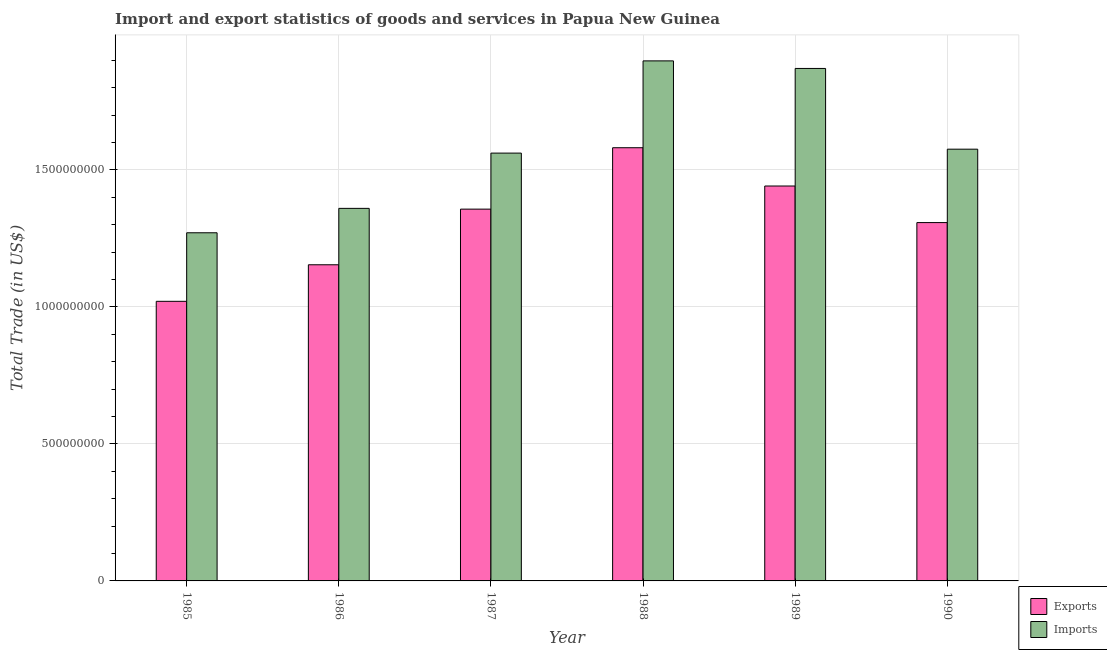How many different coloured bars are there?
Offer a very short reply. 2. How many bars are there on the 6th tick from the right?
Offer a terse response. 2. In how many cases, is the number of bars for a given year not equal to the number of legend labels?
Ensure brevity in your answer.  0. What is the imports of goods and services in 1989?
Provide a succinct answer. 1.87e+09. Across all years, what is the maximum imports of goods and services?
Make the answer very short. 1.90e+09. Across all years, what is the minimum imports of goods and services?
Ensure brevity in your answer.  1.27e+09. What is the total export of goods and services in the graph?
Your response must be concise. 7.86e+09. What is the difference between the imports of goods and services in 1985 and that in 1988?
Ensure brevity in your answer.  -6.27e+08. What is the difference between the export of goods and services in 1989 and the imports of goods and services in 1987?
Keep it short and to the point. 8.45e+07. What is the average imports of goods and services per year?
Your answer should be very brief. 1.59e+09. In how many years, is the export of goods and services greater than 200000000 US$?
Ensure brevity in your answer.  6. What is the ratio of the export of goods and services in 1989 to that in 1990?
Offer a very short reply. 1.1. Is the imports of goods and services in 1988 less than that in 1989?
Make the answer very short. No. What is the difference between the highest and the second highest imports of goods and services?
Provide a succinct answer. 2.76e+07. What is the difference between the highest and the lowest imports of goods and services?
Make the answer very short. 6.27e+08. What does the 2nd bar from the left in 1990 represents?
Make the answer very short. Imports. What does the 1st bar from the right in 1989 represents?
Offer a very short reply. Imports. How many bars are there?
Your answer should be compact. 12. Are all the bars in the graph horizontal?
Keep it short and to the point. No. What is the difference between two consecutive major ticks on the Y-axis?
Your answer should be very brief. 5.00e+08. Where does the legend appear in the graph?
Give a very brief answer. Bottom right. How are the legend labels stacked?
Give a very brief answer. Vertical. What is the title of the graph?
Provide a short and direct response. Import and export statistics of goods and services in Papua New Guinea. Does "Goods and services" appear as one of the legend labels in the graph?
Your response must be concise. No. What is the label or title of the X-axis?
Provide a short and direct response. Year. What is the label or title of the Y-axis?
Provide a succinct answer. Total Trade (in US$). What is the Total Trade (in US$) of Exports in 1985?
Offer a very short reply. 1.02e+09. What is the Total Trade (in US$) of Imports in 1985?
Provide a succinct answer. 1.27e+09. What is the Total Trade (in US$) in Exports in 1986?
Offer a terse response. 1.15e+09. What is the Total Trade (in US$) in Imports in 1986?
Your response must be concise. 1.36e+09. What is the Total Trade (in US$) of Exports in 1987?
Keep it short and to the point. 1.36e+09. What is the Total Trade (in US$) in Imports in 1987?
Keep it short and to the point. 1.56e+09. What is the Total Trade (in US$) of Exports in 1988?
Offer a terse response. 1.58e+09. What is the Total Trade (in US$) in Imports in 1988?
Offer a very short reply. 1.90e+09. What is the Total Trade (in US$) in Exports in 1989?
Keep it short and to the point. 1.44e+09. What is the Total Trade (in US$) in Imports in 1989?
Your answer should be very brief. 1.87e+09. What is the Total Trade (in US$) in Exports in 1990?
Your response must be concise. 1.31e+09. What is the Total Trade (in US$) in Imports in 1990?
Provide a short and direct response. 1.58e+09. Across all years, what is the maximum Total Trade (in US$) in Exports?
Provide a succinct answer. 1.58e+09. Across all years, what is the maximum Total Trade (in US$) in Imports?
Your answer should be compact. 1.90e+09. Across all years, what is the minimum Total Trade (in US$) of Exports?
Make the answer very short. 1.02e+09. Across all years, what is the minimum Total Trade (in US$) of Imports?
Provide a short and direct response. 1.27e+09. What is the total Total Trade (in US$) in Exports in the graph?
Offer a terse response. 7.86e+09. What is the total Total Trade (in US$) of Imports in the graph?
Keep it short and to the point. 9.54e+09. What is the difference between the Total Trade (in US$) in Exports in 1985 and that in 1986?
Your response must be concise. -1.33e+08. What is the difference between the Total Trade (in US$) in Imports in 1985 and that in 1986?
Provide a short and direct response. -8.91e+07. What is the difference between the Total Trade (in US$) in Exports in 1985 and that in 1987?
Your response must be concise. -3.36e+08. What is the difference between the Total Trade (in US$) in Imports in 1985 and that in 1987?
Your response must be concise. -2.91e+08. What is the difference between the Total Trade (in US$) in Exports in 1985 and that in 1988?
Provide a short and direct response. -5.61e+08. What is the difference between the Total Trade (in US$) of Imports in 1985 and that in 1988?
Keep it short and to the point. -6.27e+08. What is the difference between the Total Trade (in US$) in Exports in 1985 and that in 1989?
Give a very brief answer. -4.21e+08. What is the difference between the Total Trade (in US$) of Imports in 1985 and that in 1989?
Ensure brevity in your answer.  -6.00e+08. What is the difference between the Total Trade (in US$) of Exports in 1985 and that in 1990?
Provide a succinct answer. -2.87e+08. What is the difference between the Total Trade (in US$) of Imports in 1985 and that in 1990?
Your response must be concise. -3.05e+08. What is the difference between the Total Trade (in US$) in Exports in 1986 and that in 1987?
Your answer should be compact. -2.03e+08. What is the difference between the Total Trade (in US$) in Imports in 1986 and that in 1987?
Your answer should be very brief. -2.02e+08. What is the difference between the Total Trade (in US$) in Exports in 1986 and that in 1988?
Make the answer very short. -4.27e+08. What is the difference between the Total Trade (in US$) of Imports in 1986 and that in 1988?
Keep it short and to the point. -5.38e+08. What is the difference between the Total Trade (in US$) in Exports in 1986 and that in 1989?
Offer a very short reply. -2.88e+08. What is the difference between the Total Trade (in US$) of Imports in 1986 and that in 1989?
Make the answer very short. -5.11e+08. What is the difference between the Total Trade (in US$) of Exports in 1986 and that in 1990?
Keep it short and to the point. -1.54e+08. What is the difference between the Total Trade (in US$) of Imports in 1986 and that in 1990?
Offer a terse response. -2.16e+08. What is the difference between the Total Trade (in US$) of Exports in 1987 and that in 1988?
Offer a very short reply. -2.24e+08. What is the difference between the Total Trade (in US$) in Imports in 1987 and that in 1988?
Keep it short and to the point. -3.37e+08. What is the difference between the Total Trade (in US$) in Exports in 1987 and that in 1989?
Give a very brief answer. -8.45e+07. What is the difference between the Total Trade (in US$) in Imports in 1987 and that in 1989?
Your answer should be very brief. -3.09e+08. What is the difference between the Total Trade (in US$) in Exports in 1987 and that in 1990?
Offer a very short reply. 4.91e+07. What is the difference between the Total Trade (in US$) of Imports in 1987 and that in 1990?
Your response must be concise. -1.43e+07. What is the difference between the Total Trade (in US$) of Exports in 1988 and that in 1989?
Offer a very short reply. 1.40e+08. What is the difference between the Total Trade (in US$) of Imports in 1988 and that in 1989?
Your answer should be compact. 2.76e+07. What is the difference between the Total Trade (in US$) of Exports in 1988 and that in 1990?
Give a very brief answer. 2.73e+08. What is the difference between the Total Trade (in US$) of Imports in 1988 and that in 1990?
Keep it short and to the point. 3.22e+08. What is the difference between the Total Trade (in US$) of Exports in 1989 and that in 1990?
Keep it short and to the point. 1.34e+08. What is the difference between the Total Trade (in US$) in Imports in 1989 and that in 1990?
Give a very brief answer. 2.95e+08. What is the difference between the Total Trade (in US$) of Exports in 1985 and the Total Trade (in US$) of Imports in 1986?
Provide a succinct answer. -3.39e+08. What is the difference between the Total Trade (in US$) in Exports in 1985 and the Total Trade (in US$) in Imports in 1987?
Provide a short and direct response. -5.41e+08. What is the difference between the Total Trade (in US$) in Exports in 1985 and the Total Trade (in US$) in Imports in 1988?
Ensure brevity in your answer.  -8.78e+08. What is the difference between the Total Trade (in US$) of Exports in 1985 and the Total Trade (in US$) of Imports in 1989?
Offer a terse response. -8.50e+08. What is the difference between the Total Trade (in US$) in Exports in 1985 and the Total Trade (in US$) in Imports in 1990?
Make the answer very short. -5.55e+08. What is the difference between the Total Trade (in US$) of Exports in 1986 and the Total Trade (in US$) of Imports in 1987?
Your answer should be compact. -4.08e+08. What is the difference between the Total Trade (in US$) in Exports in 1986 and the Total Trade (in US$) in Imports in 1988?
Your answer should be compact. -7.44e+08. What is the difference between the Total Trade (in US$) in Exports in 1986 and the Total Trade (in US$) in Imports in 1989?
Give a very brief answer. -7.17e+08. What is the difference between the Total Trade (in US$) in Exports in 1986 and the Total Trade (in US$) in Imports in 1990?
Ensure brevity in your answer.  -4.22e+08. What is the difference between the Total Trade (in US$) in Exports in 1987 and the Total Trade (in US$) in Imports in 1988?
Offer a very short reply. -5.41e+08. What is the difference between the Total Trade (in US$) in Exports in 1987 and the Total Trade (in US$) in Imports in 1989?
Offer a terse response. -5.14e+08. What is the difference between the Total Trade (in US$) in Exports in 1987 and the Total Trade (in US$) in Imports in 1990?
Offer a very short reply. -2.19e+08. What is the difference between the Total Trade (in US$) of Exports in 1988 and the Total Trade (in US$) of Imports in 1989?
Your answer should be very brief. -2.89e+08. What is the difference between the Total Trade (in US$) in Exports in 1988 and the Total Trade (in US$) in Imports in 1990?
Ensure brevity in your answer.  5.29e+06. What is the difference between the Total Trade (in US$) of Exports in 1989 and the Total Trade (in US$) of Imports in 1990?
Offer a terse response. -1.34e+08. What is the average Total Trade (in US$) in Exports per year?
Your answer should be very brief. 1.31e+09. What is the average Total Trade (in US$) of Imports per year?
Offer a very short reply. 1.59e+09. In the year 1985, what is the difference between the Total Trade (in US$) in Exports and Total Trade (in US$) in Imports?
Your answer should be compact. -2.50e+08. In the year 1986, what is the difference between the Total Trade (in US$) of Exports and Total Trade (in US$) of Imports?
Your answer should be very brief. -2.06e+08. In the year 1987, what is the difference between the Total Trade (in US$) of Exports and Total Trade (in US$) of Imports?
Provide a succinct answer. -2.05e+08. In the year 1988, what is the difference between the Total Trade (in US$) of Exports and Total Trade (in US$) of Imports?
Give a very brief answer. -3.17e+08. In the year 1989, what is the difference between the Total Trade (in US$) of Exports and Total Trade (in US$) of Imports?
Keep it short and to the point. -4.29e+08. In the year 1990, what is the difference between the Total Trade (in US$) in Exports and Total Trade (in US$) in Imports?
Your answer should be very brief. -2.68e+08. What is the ratio of the Total Trade (in US$) in Exports in 1985 to that in 1986?
Provide a succinct answer. 0.88. What is the ratio of the Total Trade (in US$) of Imports in 1985 to that in 1986?
Offer a terse response. 0.93. What is the ratio of the Total Trade (in US$) of Exports in 1985 to that in 1987?
Your answer should be compact. 0.75. What is the ratio of the Total Trade (in US$) in Imports in 1985 to that in 1987?
Offer a terse response. 0.81. What is the ratio of the Total Trade (in US$) of Exports in 1985 to that in 1988?
Your answer should be compact. 0.65. What is the ratio of the Total Trade (in US$) in Imports in 1985 to that in 1988?
Offer a very short reply. 0.67. What is the ratio of the Total Trade (in US$) of Exports in 1985 to that in 1989?
Your answer should be compact. 0.71. What is the ratio of the Total Trade (in US$) in Imports in 1985 to that in 1989?
Offer a very short reply. 0.68. What is the ratio of the Total Trade (in US$) in Exports in 1985 to that in 1990?
Offer a terse response. 0.78. What is the ratio of the Total Trade (in US$) in Imports in 1985 to that in 1990?
Your answer should be compact. 0.81. What is the ratio of the Total Trade (in US$) of Exports in 1986 to that in 1987?
Your answer should be very brief. 0.85. What is the ratio of the Total Trade (in US$) of Imports in 1986 to that in 1987?
Provide a succinct answer. 0.87. What is the ratio of the Total Trade (in US$) in Exports in 1986 to that in 1988?
Provide a succinct answer. 0.73. What is the ratio of the Total Trade (in US$) in Imports in 1986 to that in 1988?
Give a very brief answer. 0.72. What is the ratio of the Total Trade (in US$) in Exports in 1986 to that in 1989?
Provide a short and direct response. 0.8. What is the ratio of the Total Trade (in US$) of Imports in 1986 to that in 1989?
Give a very brief answer. 0.73. What is the ratio of the Total Trade (in US$) of Exports in 1986 to that in 1990?
Give a very brief answer. 0.88. What is the ratio of the Total Trade (in US$) of Imports in 1986 to that in 1990?
Ensure brevity in your answer.  0.86. What is the ratio of the Total Trade (in US$) in Exports in 1987 to that in 1988?
Ensure brevity in your answer.  0.86. What is the ratio of the Total Trade (in US$) of Imports in 1987 to that in 1988?
Offer a terse response. 0.82. What is the ratio of the Total Trade (in US$) in Exports in 1987 to that in 1989?
Your answer should be very brief. 0.94. What is the ratio of the Total Trade (in US$) of Imports in 1987 to that in 1989?
Your answer should be compact. 0.83. What is the ratio of the Total Trade (in US$) of Exports in 1987 to that in 1990?
Ensure brevity in your answer.  1.04. What is the ratio of the Total Trade (in US$) in Imports in 1987 to that in 1990?
Keep it short and to the point. 0.99. What is the ratio of the Total Trade (in US$) in Exports in 1988 to that in 1989?
Your answer should be very brief. 1.1. What is the ratio of the Total Trade (in US$) of Imports in 1988 to that in 1989?
Your response must be concise. 1.01. What is the ratio of the Total Trade (in US$) of Exports in 1988 to that in 1990?
Offer a terse response. 1.21. What is the ratio of the Total Trade (in US$) of Imports in 1988 to that in 1990?
Offer a terse response. 1.2. What is the ratio of the Total Trade (in US$) in Exports in 1989 to that in 1990?
Make the answer very short. 1.1. What is the ratio of the Total Trade (in US$) in Imports in 1989 to that in 1990?
Offer a terse response. 1.19. What is the difference between the highest and the second highest Total Trade (in US$) of Exports?
Provide a short and direct response. 1.40e+08. What is the difference between the highest and the second highest Total Trade (in US$) of Imports?
Provide a succinct answer. 2.76e+07. What is the difference between the highest and the lowest Total Trade (in US$) of Exports?
Your response must be concise. 5.61e+08. What is the difference between the highest and the lowest Total Trade (in US$) of Imports?
Your answer should be compact. 6.27e+08. 